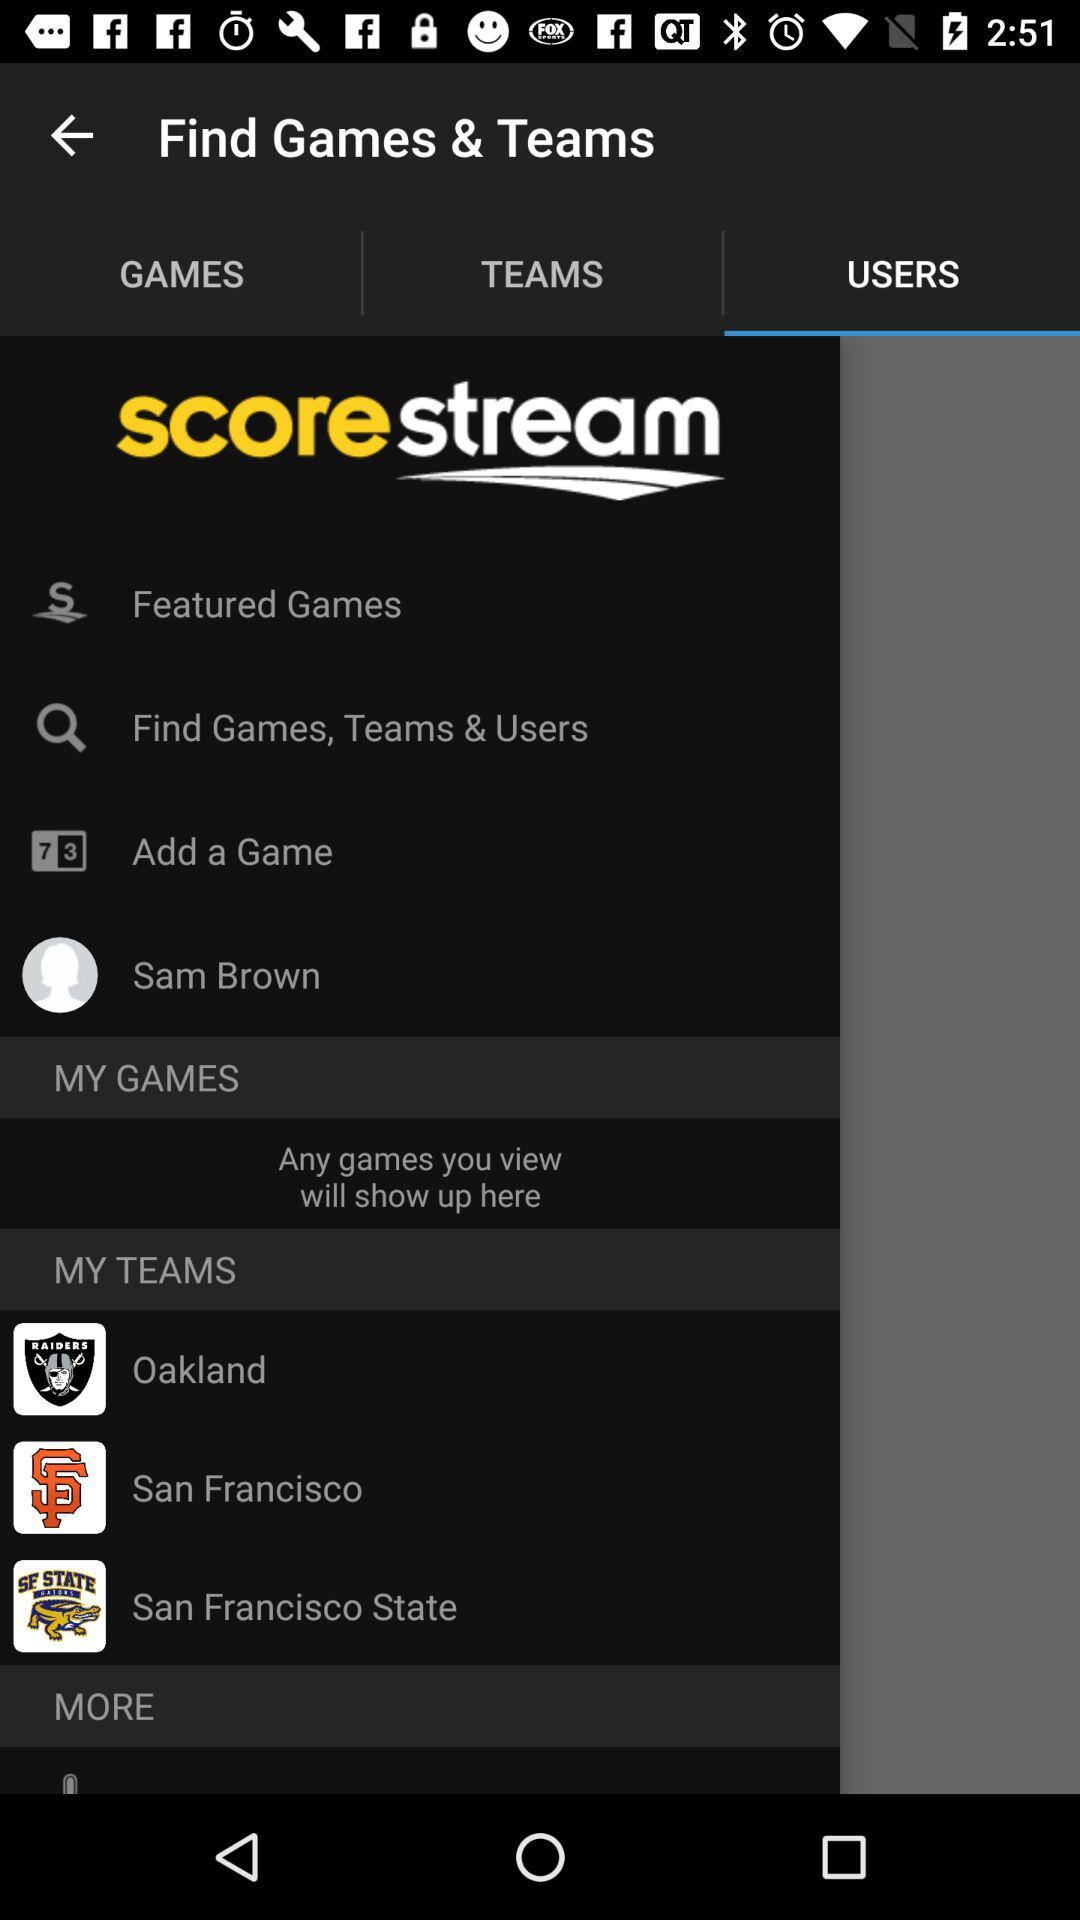What is the name of the user? The name of the user is Sam Brown. 